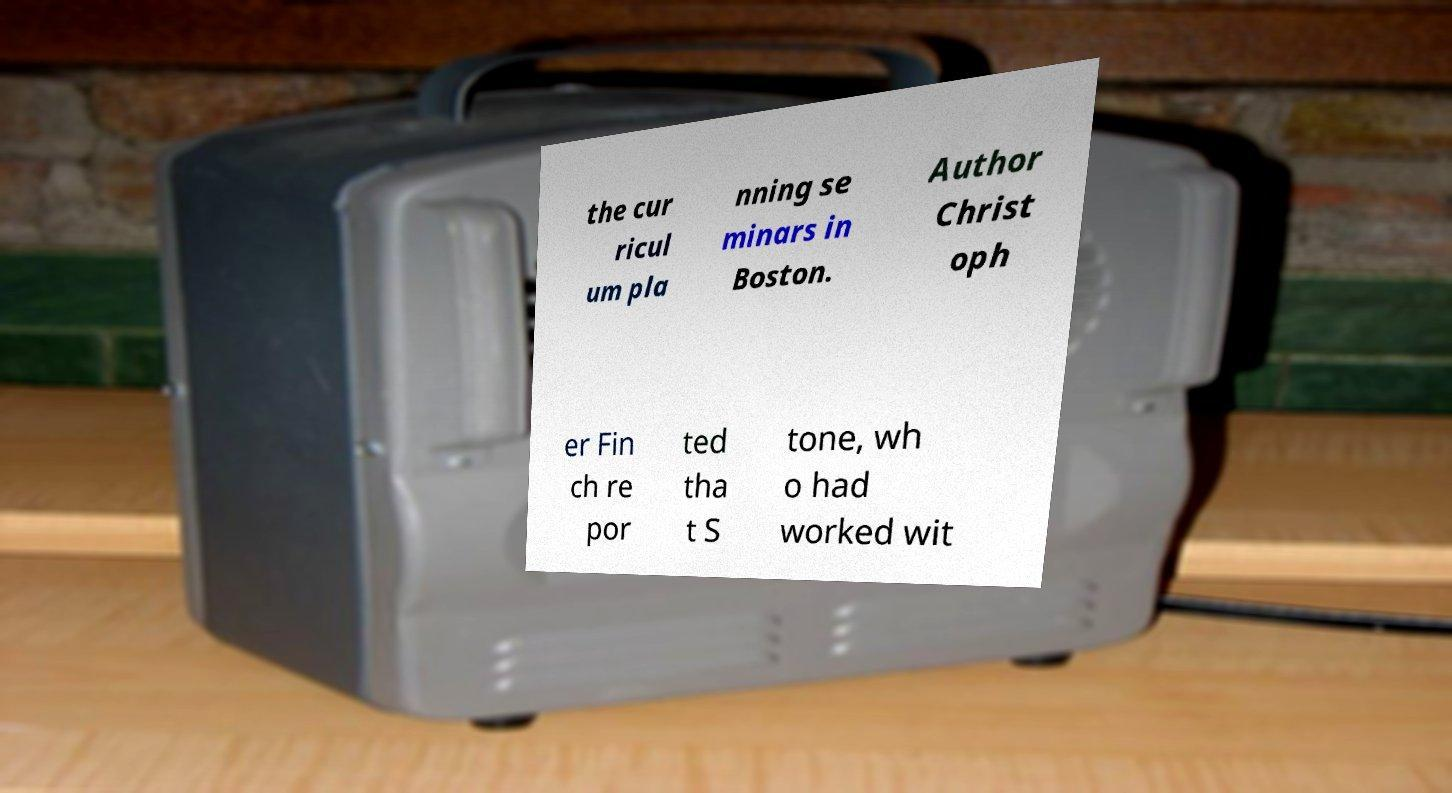Please read and relay the text visible in this image. What does it say? the cur ricul um pla nning se minars in Boston. Author Christ oph er Fin ch re por ted tha t S tone, wh o had worked wit 